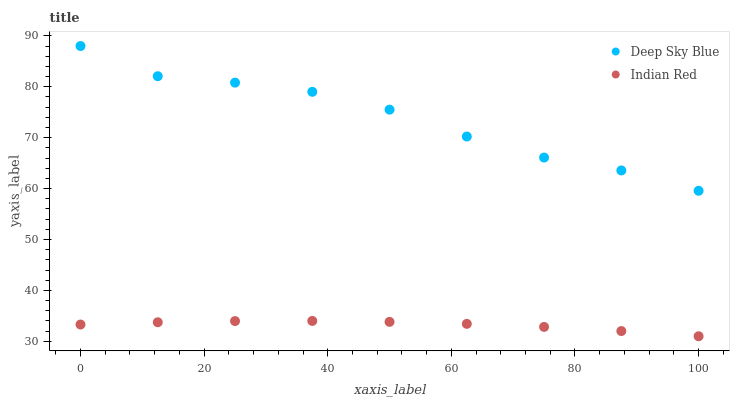Does Indian Red have the minimum area under the curve?
Answer yes or no. Yes. Does Deep Sky Blue have the maximum area under the curve?
Answer yes or no. Yes. Does Deep Sky Blue have the minimum area under the curve?
Answer yes or no. No. Is Indian Red the smoothest?
Answer yes or no. Yes. Is Deep Sky Blue the roughest?
Answer yes or no. Yes. Is Deep Sky Blue the smoothest?
Answer yes or no. No. Does Indian Red have the lowest value?
Answer yes or no. Yes. Does Deep Sky Blue have the lowest value?
Answer yes or no. No. Does Deep Sky Blue have the highest value?
Answer yes or no. Yes. Is Indian Red less than Deep Sky Blue?
Answer yes or no. Yes. Is Deep Sky Blue greater than Indian Red?
Answer yes or no. Yes. Does Indian Red intersect Deep Sky Blue?
Answer yes or no. No. 